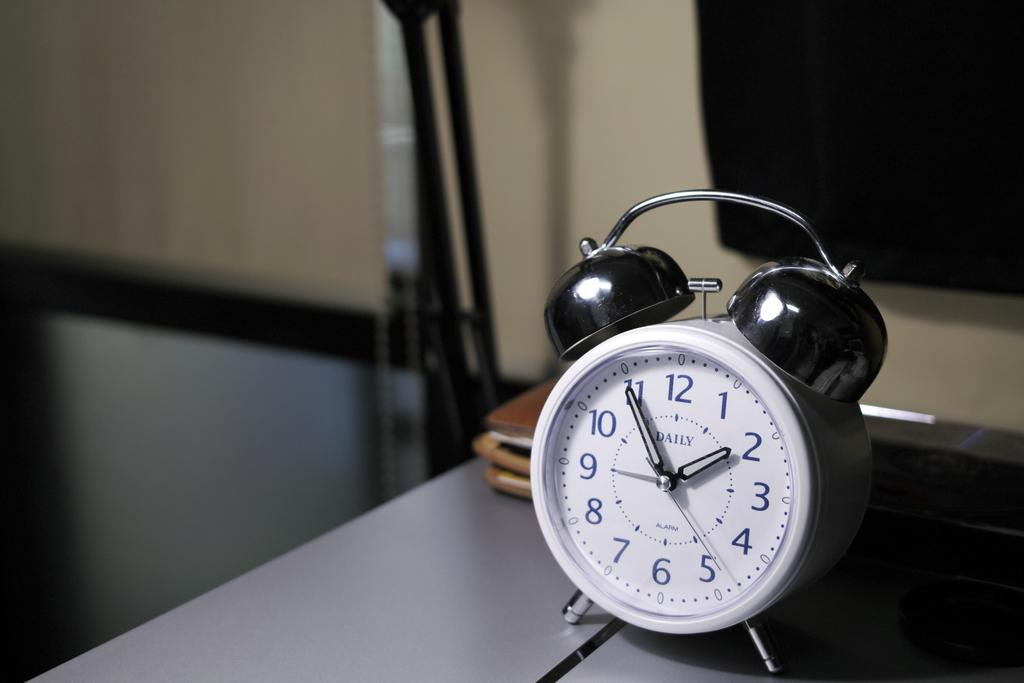<image>
Summarize the visual content of the image. A white, old fashioned, bell, Daily alarm clock reads the time as 1:49. 